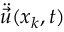<formula> <loc_0><loc_0><loc_500><loc_500>\ddot { \vec { u } } ( x _ { k } , t )</formula> 